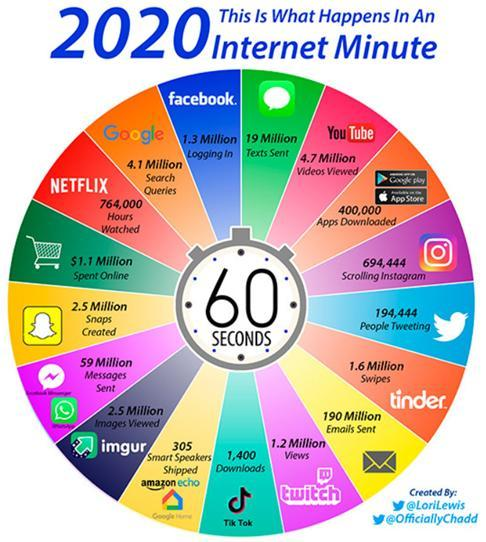How many snaps are created in 2 minutes?
Answer the question with a short phrase. 5 million How many tik tok downloads in 2 minutes? 2,800 How many Apps are downloaded in 2 minutes? 800,000 How many images are viewed in 2 minutes? 5 million How many are logging-in to facebook in 2 minutes? 2.6 million How many are scrolling instagram in 2 minutes? 1,388,888 